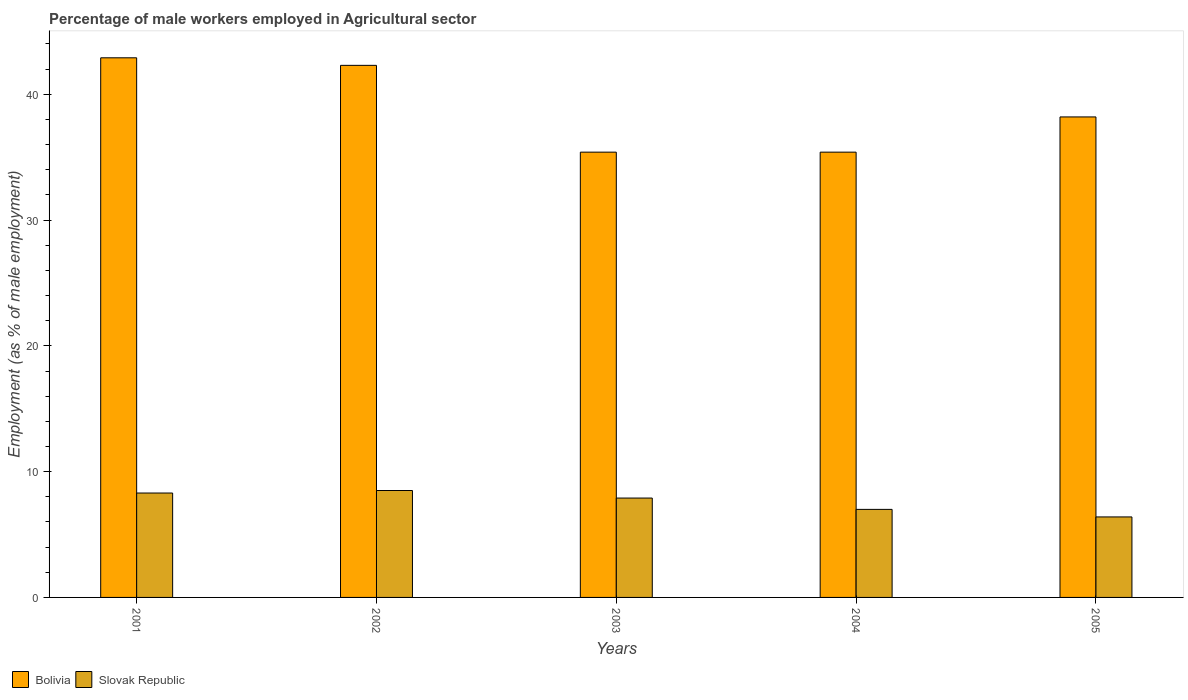How many different coloured bars are there?
Offer a terse response. 2. How many groups of bars are there?
Provide a succinct answer. 5. How many bars are there on the 1st tick from the left?
Offer a terse response. 2. In how many cases, is the number of bars for a given year not equal to the number of legend labels?
Offer a terse response. 0. What is the percentage of male workers employed in Agricultural sector in Bolivia in 2001?
Provide a short and direct response. 42.9. Across all years, what is the maximum percentage of male workers employed in Agricultural sector in Bolivia?
Your answer should be very brief. 42.9. Across all years, what is the minimum percentage of male workers employed in Agricultural sector in Slovak Republic?
Give a very brief answer. 6.4. In which year was the percentage of male workers employed in Agricultural sector in Bolivia maximum?
Ensure brevity in your answer.  2001. What is the total percentage of male workers employed in Agricultural sector in Slovak Republic in the graph?
Keep it short and to the point. 38.1. What is the difference between the percentage of male workers employed in Agricultural sector in Bolivia in 2001 and that in 2003?
Give a very brief answer. 7.5. What is the difference between the percentage of male workers employed in Agricultural sector in Bolivia in 2001 and the percentage of male workers employed in Agricultural sector in Slovak Republic in 2004?
Provide a short and direct response. 35.9. What is the average percentage of male workers employed in Agricultural sector in Slovak Republic per year?
Your answer should be compact. 7.62. In the year 2003, what is the difference between the percentage of male workers employed in Agricultural sector in Bolivia and percentage of male workers employed in Agricultural sector in Slovak Republic?
Ensure brevity in your answer.  27.5. What is the ratio of the percentage of male workers employed in Agricultural sector in Bolivia in 2001 to that in 2003?
Your response must be concise. 1.21. Is the difference between the percentage of male workers employed in Agricultural sector in Bolivia in 2002 and 2004 greater than the difference between the percentage of male workers employed in Agricultural sector in Slovak Republic in 2002 and 2004?
Your answer should be compact. Yes. What is the difference between the highest and the second highest percentage of male workers employed in Agricultural sector in Bolivia?
Keep it short and to the point. 0.6. What is the difference between the highest and the lowest percentage of male workers employed in Agricultural sector in Slovak Republic?
Provide a succinct answer. 2.1. In how many years, is the percentage of male workers employed in Agricultural sector in Bolivia greater than the average percentage of male workers employed in Agricultural sector in Bolivia taken over all years?
Give a very brief answer. 2. What does the 1st bar from the right in 2003 represents?
Provide a succinct answer. Slovak Republic. Are the values on the major ticks of Y-axis written in scientific E-notation?
Your response must be concise. No. Does the graph contain any zero values?
Provide a short and direct response. No. How many legend labels are there?
Keep it short and to the point. 2. How are the legend labels stacked?
Make the answer very short. Horizontal. What is the title of the graph?
Your answer should be compact. Percentage of male workers employed in Agricultural sector. What is the label or title of the Y-axis?
Offer a terse response. Employment (as % of male employment). What is the Employment (as % of male employment) in Bolivia in 2001?
Ensure brevity in your answer.  42.9. What is the Employment (as % of male employment) of Slovak Republic in 2001?
Give a very brief answer. 8.3. What is the Employment (as % of male employment) of Bolivia in 2002?
Provide a short and direct response. 42.3. What is the Employment (as % of male employment) in Slovak Republic in 2002?
Ensure brevity in your answer.  8.5. What is the Employment (as % of male employment) in Bolivia in 2003?
Offer a very short reply. 35.4. What is the Employment (as % of male employment) in Slovak Republic in 2003?
Offer a terse response. 7.9. What is the Employment (as % of male employment) in Bolivia in 2004?
Keep it short and to the point. 35.4. What is the Employment (as % of male employment) in Slovak Republic in 2004?
Your answer should be compact. 7. What is the Employment (as % of male employment) in Bolivia in 2005?
Keep it short and to the point. 38.2. What is the Employment (as % of male employment) of Slovak Republic in 2005?
Make the answer very short. 6.4. Across all years, what is the maximum Employment (as % of male employment) in Bolivia?
Your response must be concise. 42.9. Across all years, what is the minimum Employment (as % of male employment) in Bolivia?
Your answer should be compact. 35.4. Across all years, what is the minimum Employment (as % of male employment) in Slovak Republic?
Ensure brevity in your answer.  6.4. What is the total Employment (as % of male employment) in Bolivia in the graph?
Your answer should be compact. 194.2. What is the total Employment (as % of male employment) of Slovak Republic in the graph?
Offer a very short reply. 38.1. What is the difference between the Employment (as % of male employment) in Bolivia in 2001 and that in 2002?
Your answer should be very brief. 0.6. What is the difference between the Employment (as % of male employment) of Bolivia in 2001 and that in 2003?
Keep it short and to the point. 7.5. What is the difference between the Employment (as % of male employment) in Bolivia in 2001 and that in 2004?
Offer a very short reply. 7.5. What is the difference between the Employment (as % of male employment) of Slovak Republic in 2001 and that in 2004?
Ensure brevity in your answer.  1.3. What is the difference between the Employment (as % of male employment) in Bolivia in 2001 and that in 2005?
Give a very brief answer. 4.7. What is the difference between the Employment (as % of male employment) of Bolivia in 2002 and that in 2004?
Your response must be concise. 6.9. What is the difference between the Employment (as % of male employment) in Bolivia in 2002 and that in 2005?
Your response must be concise. 4.1. What is the difference between the Employment (as % of male employment) of Slovak Republic in 2002 and that in 2005?
Offer a terse response. 2.1. What is the difference between the Employment (as % of male employment) of Bolivia in 2003 and that in 2005?
Offer a very short reply. -2.8. What is the difference between the Employment (as % of male employment) in Slovak Republic in 2003 and that in 2005?
Offer a terse response. 1.5. What is the difference between the Employment (as % of male employment) in Bolivia in 2004 and that in 2005?
Your answer should be compact. -2.8. What is the difference between the Employment (as % of male employment) of Slovak Republic in 2004 and that in 2005?
Provide a succinct answer. 0.6. What is the difference between the Employment (as % of male employment) in Bolivia in 2001 and the Employment (as % of male employment) in Slovak Republic in 2002?
Your answer should be very brief. 34.4. What is the difference between the Employment (as % of male employment) of Bolivia in 2001 and the Employment (as % of male employment) of Slovak Republic in 2003?
Your response must be concise. 35. What is the difference between the Employment (as % of male employment) in Bolivia in 2001 and the Employment (as % of male employment) in Slovak Republic in 2004?
Ensure brevity in your answer.  35.9. What is the difference between the Employment (as % of male employment) of Bolivia in 2001 and the Employment (as % of male employment) of Slovak Republic in 2005?
Your answer should be very brief. 36.5. What is the difference between the Employment (as % of male employment) of Bolivia in 2002 and the Employment (as % of male employment) of Slovak Republic in 2003?
Keep it short and to the point. 34.4. What is the difference between the Employment (as % of male employment) in Bolivia in 2002 and the Employment (as % of male employment) in Slovak Republic in 2004?
Your answer should be very brief. 35.3. What is the difference between the Employment (as % of male employment) in Bolivia in 2002 and the Employment (as % of male employment) in Slovak Republic in 2005?
Your response must be concise. 35.9. What is the difference between the Employment (as % of male employment) in Bolivia in 2003 and the Employment (as % of male employment) in Slovak Republic in 2004?
Your answer should be compact. 28.4. What is the difference between the Employment (as % of male employment) in Bolivia in 2004 and the Employment (as % of male employment) in Slovak Republic in 2005?
Your response must be concise. 29. What is the average Employment (as % of male employment) in Bolivia per year?
Your answer should be very brief. 38.84. What is the average Employment (as % of male employment) in Slovak Republic per year?
Your response must be concise. 7.62. In the year 2001, what is the difference between the Employment (as % of male employment) of Bolivia and Employment (as % of male employment) of Slovak Republic?
Your answer should be compact. 34.6. In the year 2002, what is the difference between the Employment (as % of male employment) of Bolivia and Employment (as % of male employment) of Slovak Republic?
Keep it short and to the point. 33.8. In the year 2003, what is the difference between the Employment (as % of male employment) of Bolivia and Employment (as % of male employment) of Slovak Republic?
Offer a terse response. 27.5. In the year 2004, what is the difference between the Employment (as % of male employment) in Bolivia and Employment (as % of male employment) in Slovak Republic?
Give a very brief answer. 28.4. In the year 2005, what is the difference between the Employment (as % of male employment) of Bolivia and Employment (as % of male employment) of Slovak Republic?
Make the answer very short. 31.8. What is the ratio of the Employment (as % of male employment) of Bolivia in 2001 to that in 2002?
Offer a terse response. 1.01. What is the ratio of the Employment (as % of male employment) of Slovak Republic in 2001 to that in 2002?
Provide a short and direct response. 0.98. What is the ratio of the Employment (as % of male employment) in Bolivia in 2001 to that in 2003?
Provide a short and direct response. 1.21. What is the ratio of the Employment (as % of male employment) of Slovak Republic in 2001 to that in 2003?
Your answer should be compact. 1.05. What is the ratio of the Employment (as % of male employment) in Bolivia in 2001 to that in 2004?
Offer a terse response. 1.21. What is the ratio of the Employment (as % of male employment) in Slovak Republic in 2001 to that in 2004?
Provide a succinct answer. 1.19. What is the ratio of the Employment (as % of male employment) in Bolivia in 2001 to that in 2005?
Provide a succinct answer. 1.12. What is the ratio of the Employment (as % of male employment) of Slovak Republic in 2001 to that in 2005?
Offer a terse response. 1.3. What is the ratio of the Employment (as % of male employment) of Bolivia in 2002 to that in 2003?
Ensure brevity in your answer.  1.19. What is the ratio of the Employment (as % of male employment) in Slovak Republic in 2002 to that in 2003?
Offer a terse response. 1.08. What is the ratio of the Employment (as % of male employment) of Bolivia in 2002 to that in 2004?
Make the answer very short. 1.19. What is the ratio of the Employment (as % of male employment) in Slovak Republic in 2002 to that in 2004?
Give a very brief answer. 1.21. What is the ratio of the Employment (as % of male employment) of Bolivia in 2002 to that in 2005?
Provide a succinct answer. 1.11. What is the ratio of the Employment (as % of male employment) in Slovak Republic in 2002 to that in 2005?
Provide a succinct answer. 1.33. What is the ratio of the Employment (as % of male employment) of Bolivia in 2003 to that in 2004?
Offer a terse response. 1. What is the ratio of the Employment (as % of male employment) in Slovak Republic in 2003 to that in 2004?
Your answer should be compact. 1.13. What is the ratio of the Employment (as % of male employment) in Bolivia in 2003 to that in 2005?
Make the answer very short. 0.93. What is the ratio of the Employment (as % of male employment) of Slovak Republic in 2003 to that in 2005?
Provide a succinct answer. 1.23. What is the ratio of the Employment (as % of male employment) in Bolivia in 2004 to that in 2005?
Give a very brief answer. 0.93. What is the ratio of the Employment (as % of male employment) of Slovak Republic in 2004 to that in 2005?
Offer a very short reply. 1.09. 